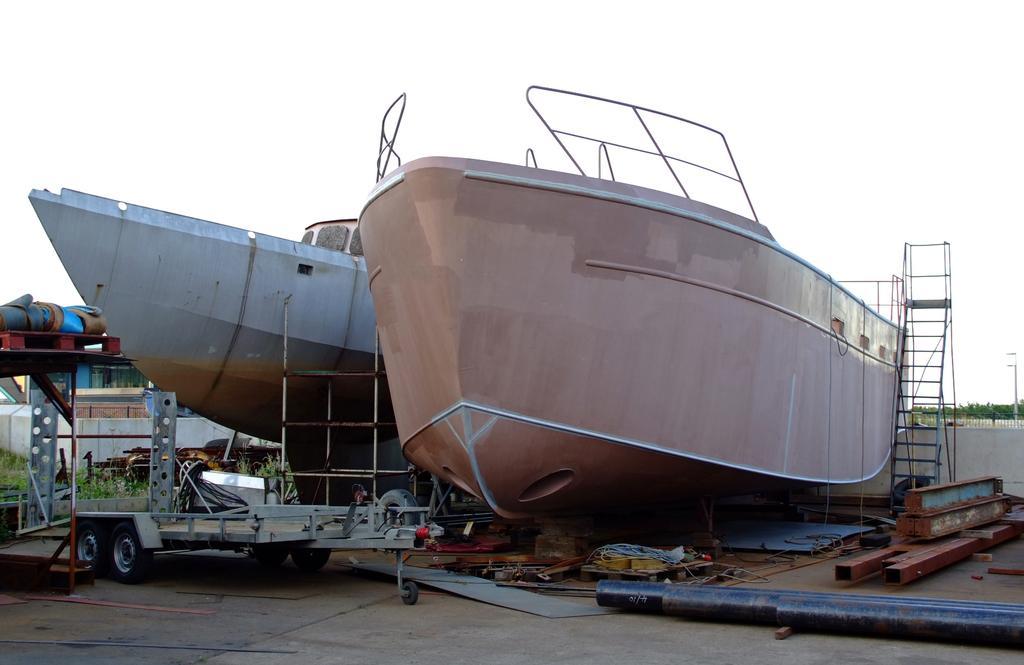Can you describe this image briefly? In the image there are ships with railings. On the right side of the image there is a ladder. At the bottom of the image on the floor there are many iron objects like rods and some other things. Behind them there on the ground there is grass and also there are walls. At the top of the image there is sky. 